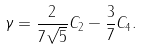<formula> <loc_0><loc_0><loc_500><loc_500>\gamma = \frac { 2 } { 7 \sqrt { 5 } } C _ { 2 } - \frac { 3 } { 7 } C _ { 4 } .</formula> 